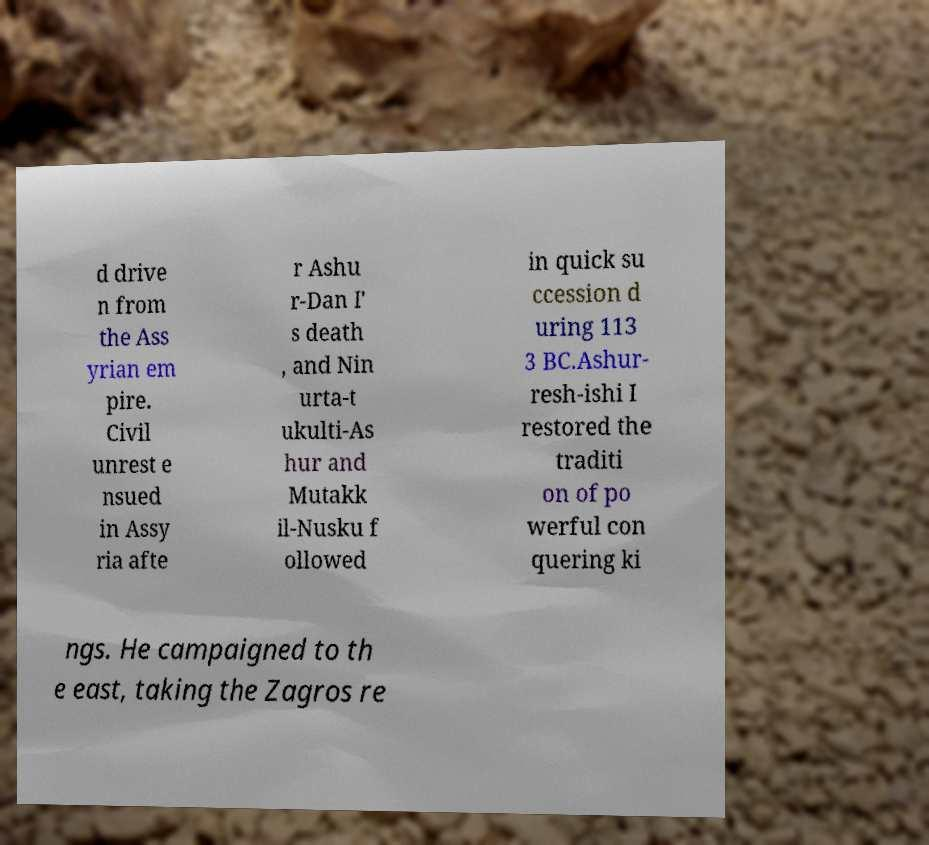Could you extract and type out the text from this image? d drive n from the Ass yrian em pire. Civil unrest e nsued in Assy ria afte r Ashu r-Dan I' s death , and Nin urta-t ukulti-As hur and Mutakk il-Nusku f ollowed in quick su ccession d uring 113 3 BC.Ashur- resh-ishi I restored the traditi on of po werful con quering ki ngs. He campaigned to th e east, taking the Zagros re 